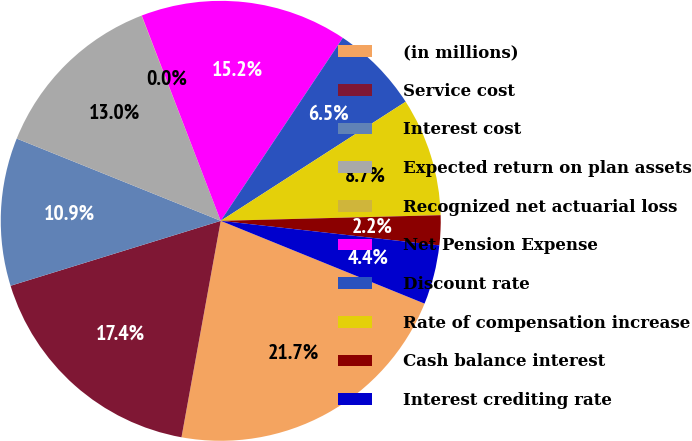Convert chart to OTSL. <chart><loc_0><loc_0><loc_500><loc_500><pie_chart><fcel>(in millions)<fcel>Service cost<fcel>Interest cost<fcel>Expected return on plan assets<fcel>Recognized net actuarial loss<fcel>Net Pension Expense<fcel>Discount rate<fcel>Rate of compensation increase<fcel>Cash balance interest<fcel>Interest crediting rate<nl><fcel>21.72%<fcel>17.38%<fcel>10.87%<fcel>13.04%<fcel>0.02%<fcel>15.21%<fcel>6.53%<fcel>8.7%<fcel>2.19%<fcel>4.36%<nl></chart> 